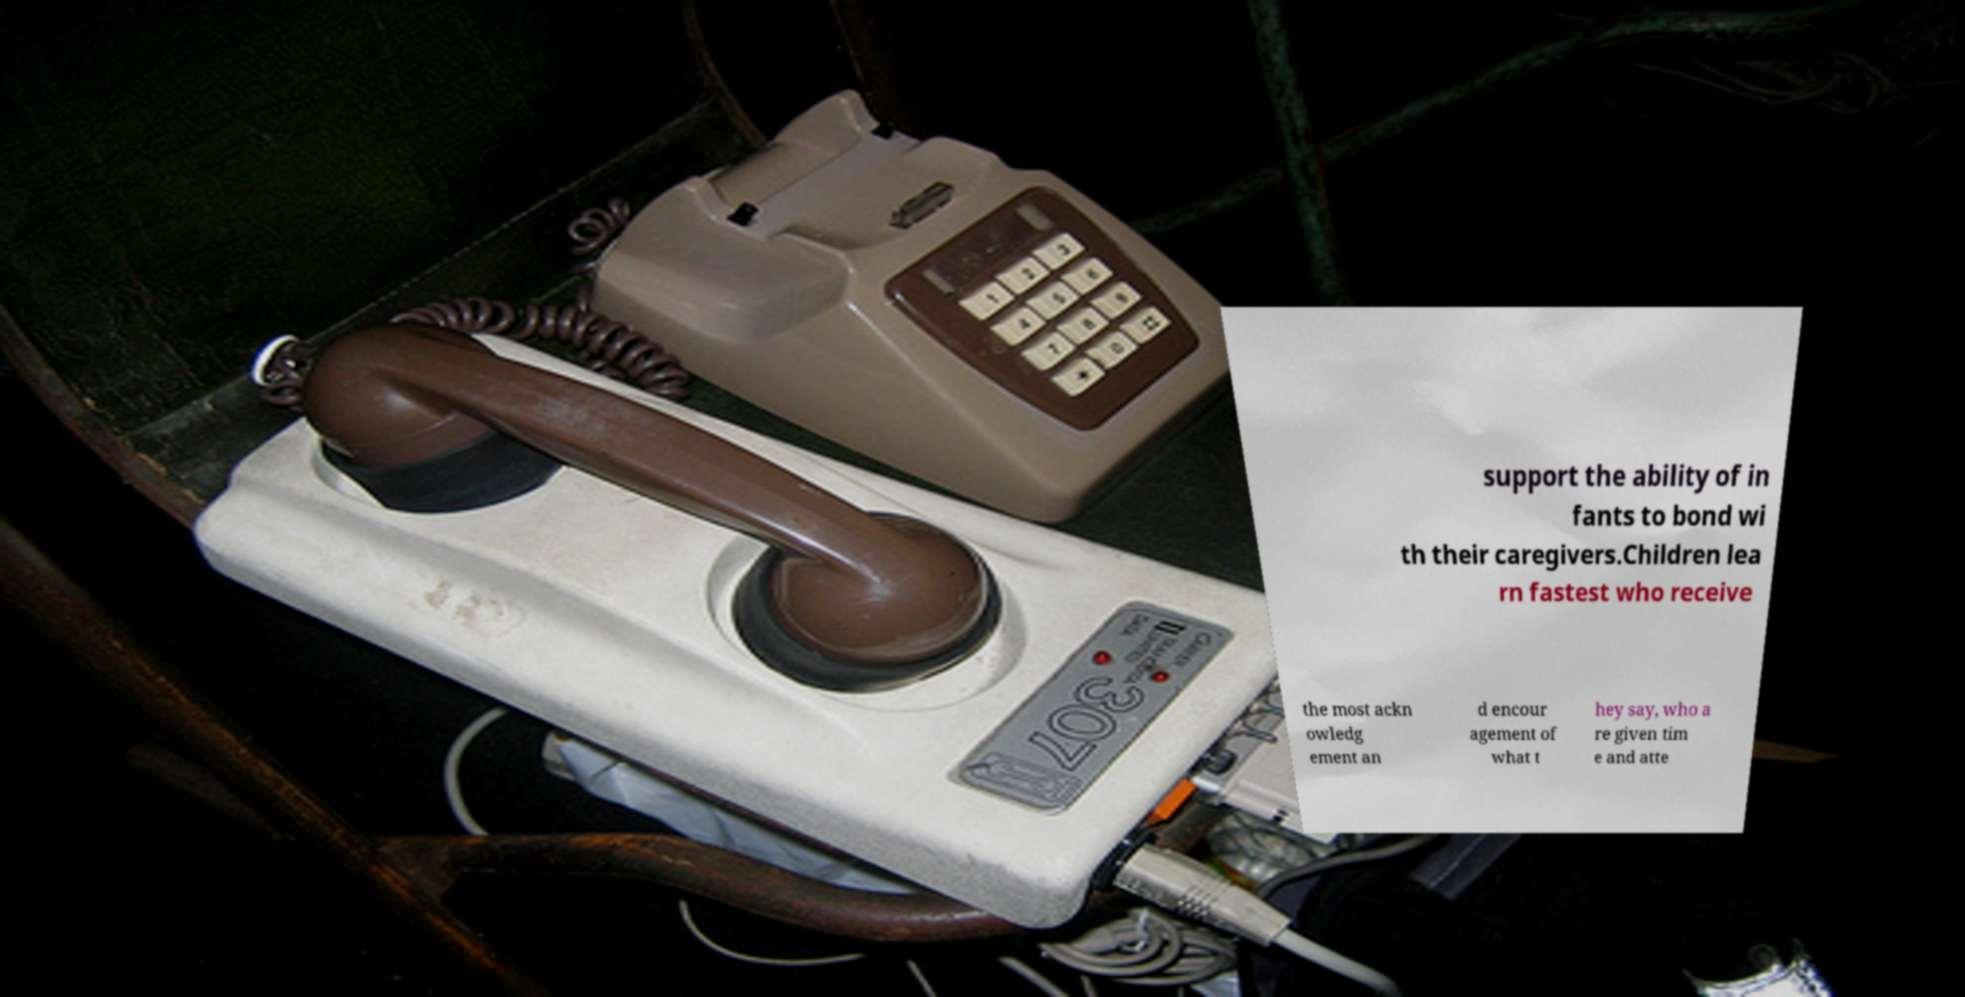Could you assist in decoding the text presented in this image and type it out clearly? support the ability of in fants to bond wi th their caregivers.Children lea rn fastest who receive the most ackn owledg ement an d encour agement of what t hey say, who a re given tim e and atte 